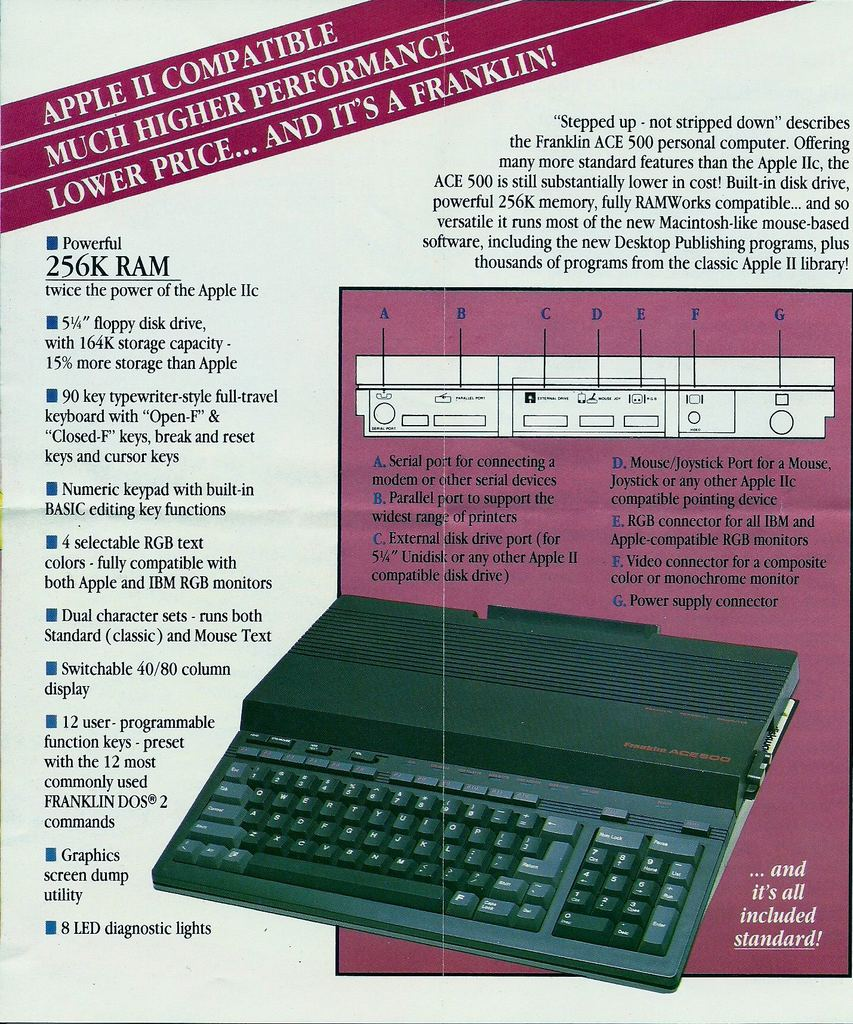What makes this computer a significant offering at the time of its release? The Franklin ACE 500 was significant for offering a competitive alternative to the Apple II series. It boasted Apple II compatibility, which meant it could run the vast library of Apple II software, but it also included enhancements like more RAM and added features that were not standard on the Apple II, all while being offered at a lower price point. This provided consumers with a valuable choice in a market previously dominated by Apple's computers. 